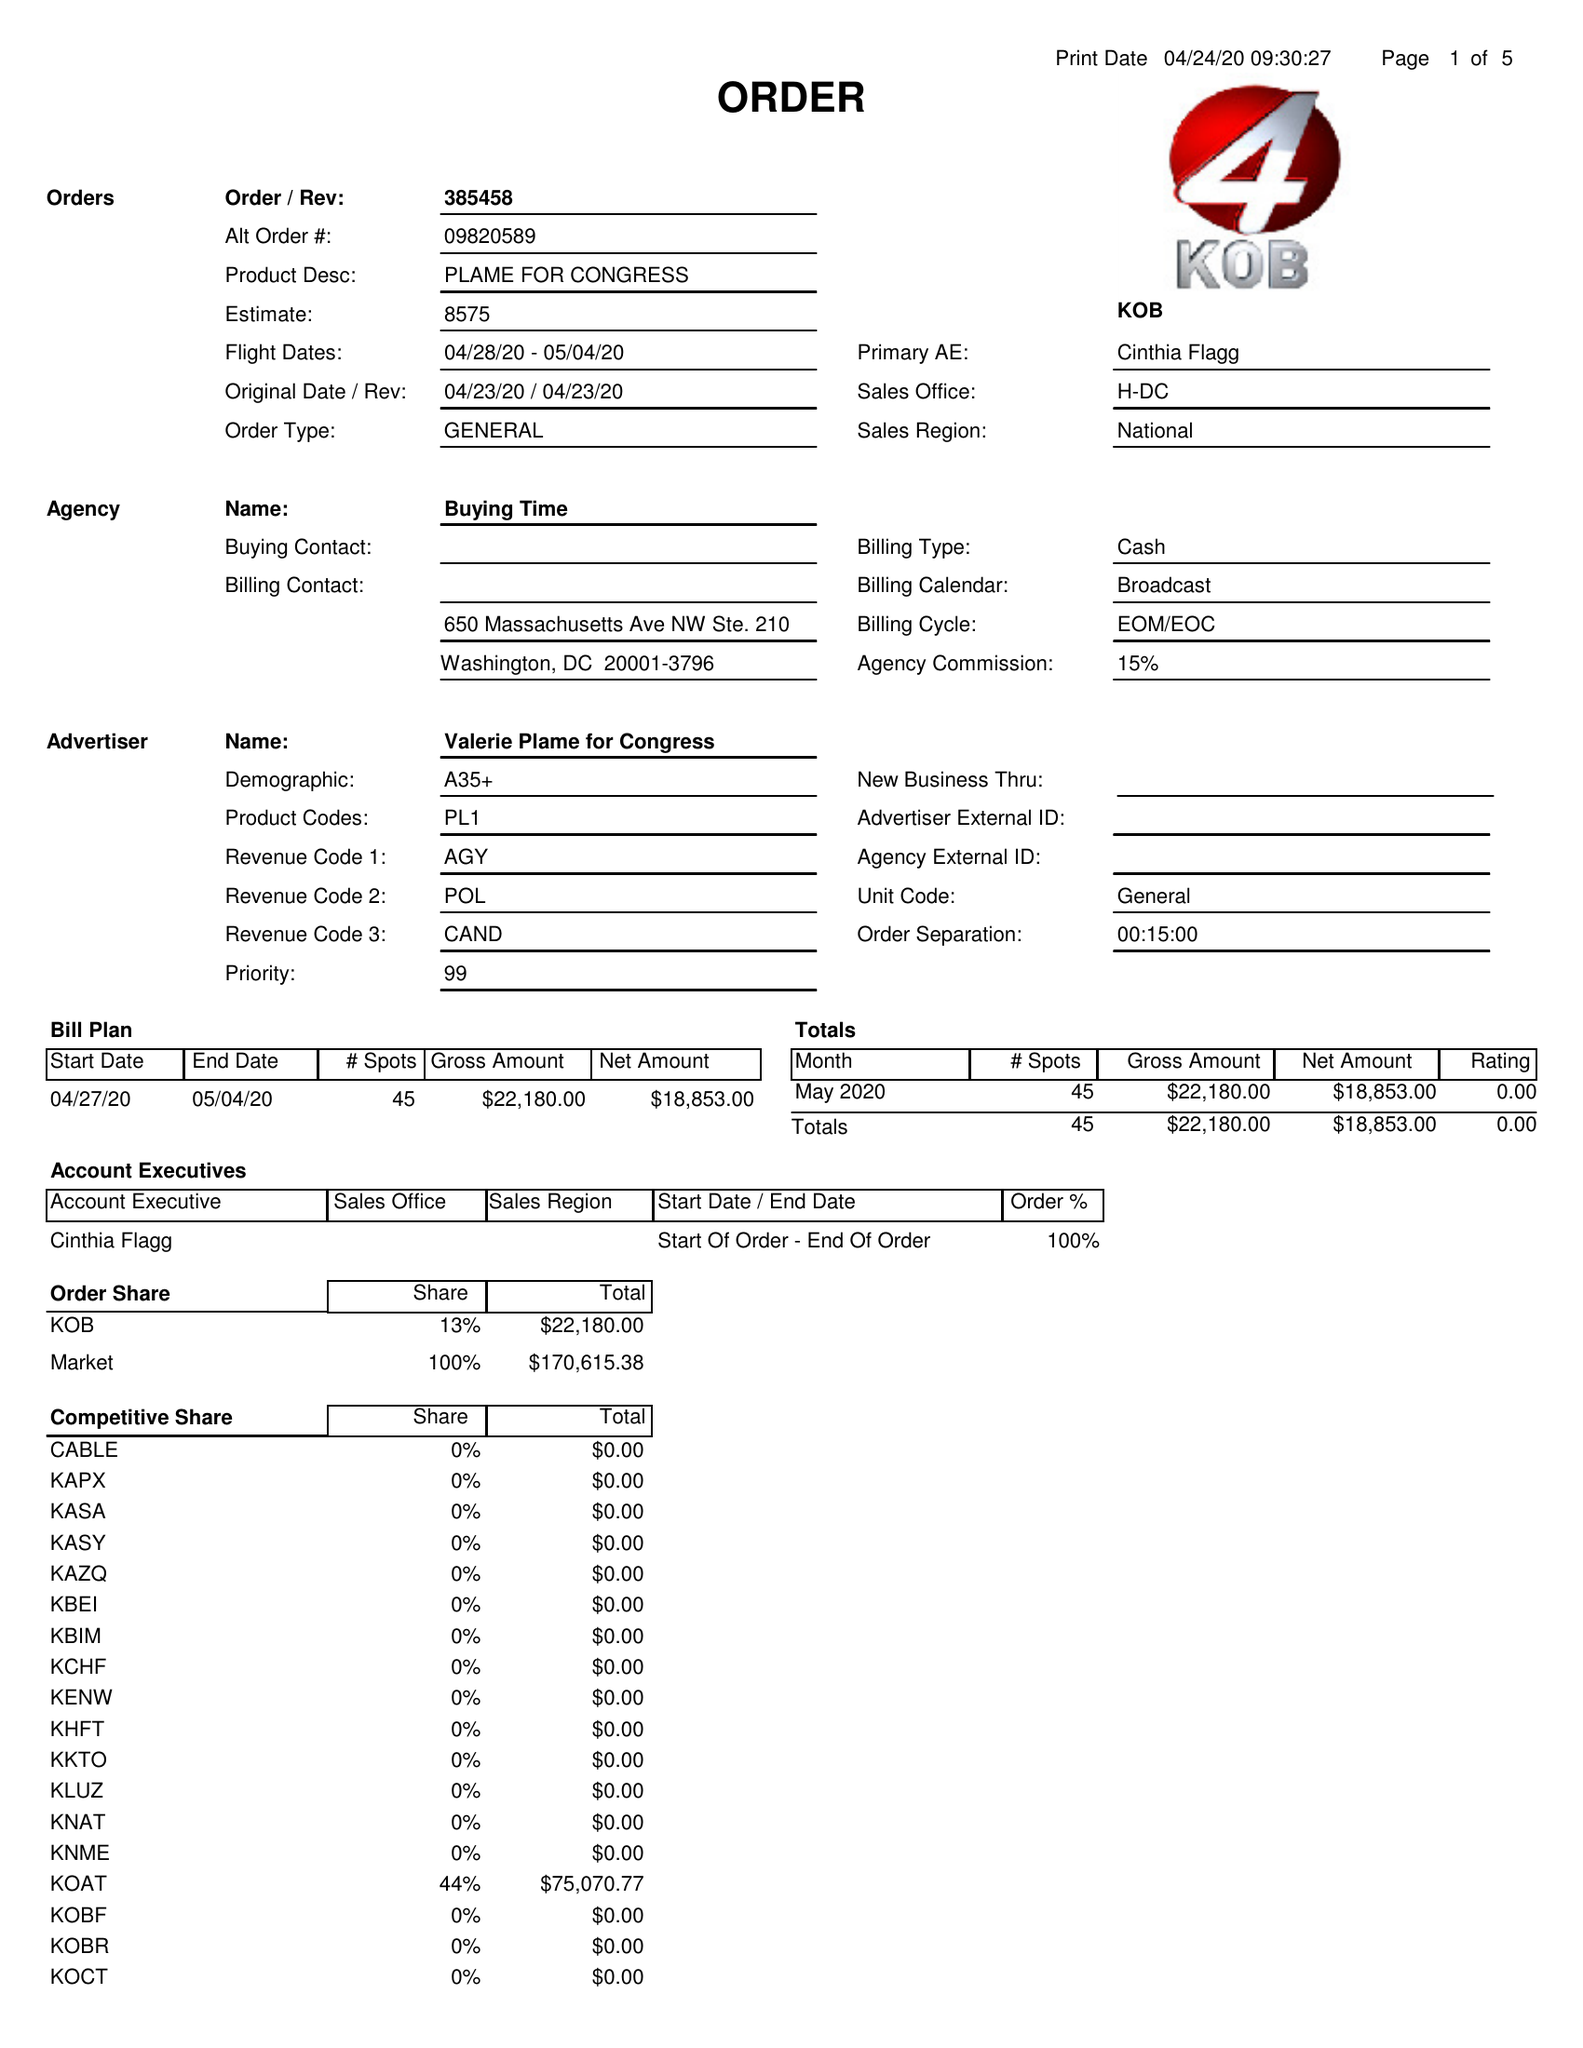What is the value for the gross_amount?
Answer the question using a single word or phrase. 22180.00 